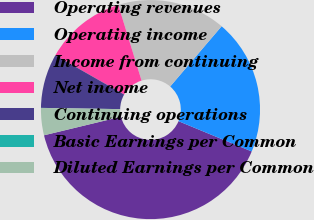Convert chart to OTSL. <chart><loc_0><loc_0><loc_500><loc_500><pie_chart><fcel>Operating revenues<fcel>Operating income<fcel>Income from continuing<fcel>Net income<fcel>Continuing operations<fcel>Basic Earnings per Common<fcel>Diluted Earnings per Common<nl><fcel>39.99%<fcel>20.0%<fcel>16.0%<fcel>12.0%<fcel>8.0%<fcel>0.01%<fcel>4.01%<nl></chart> 